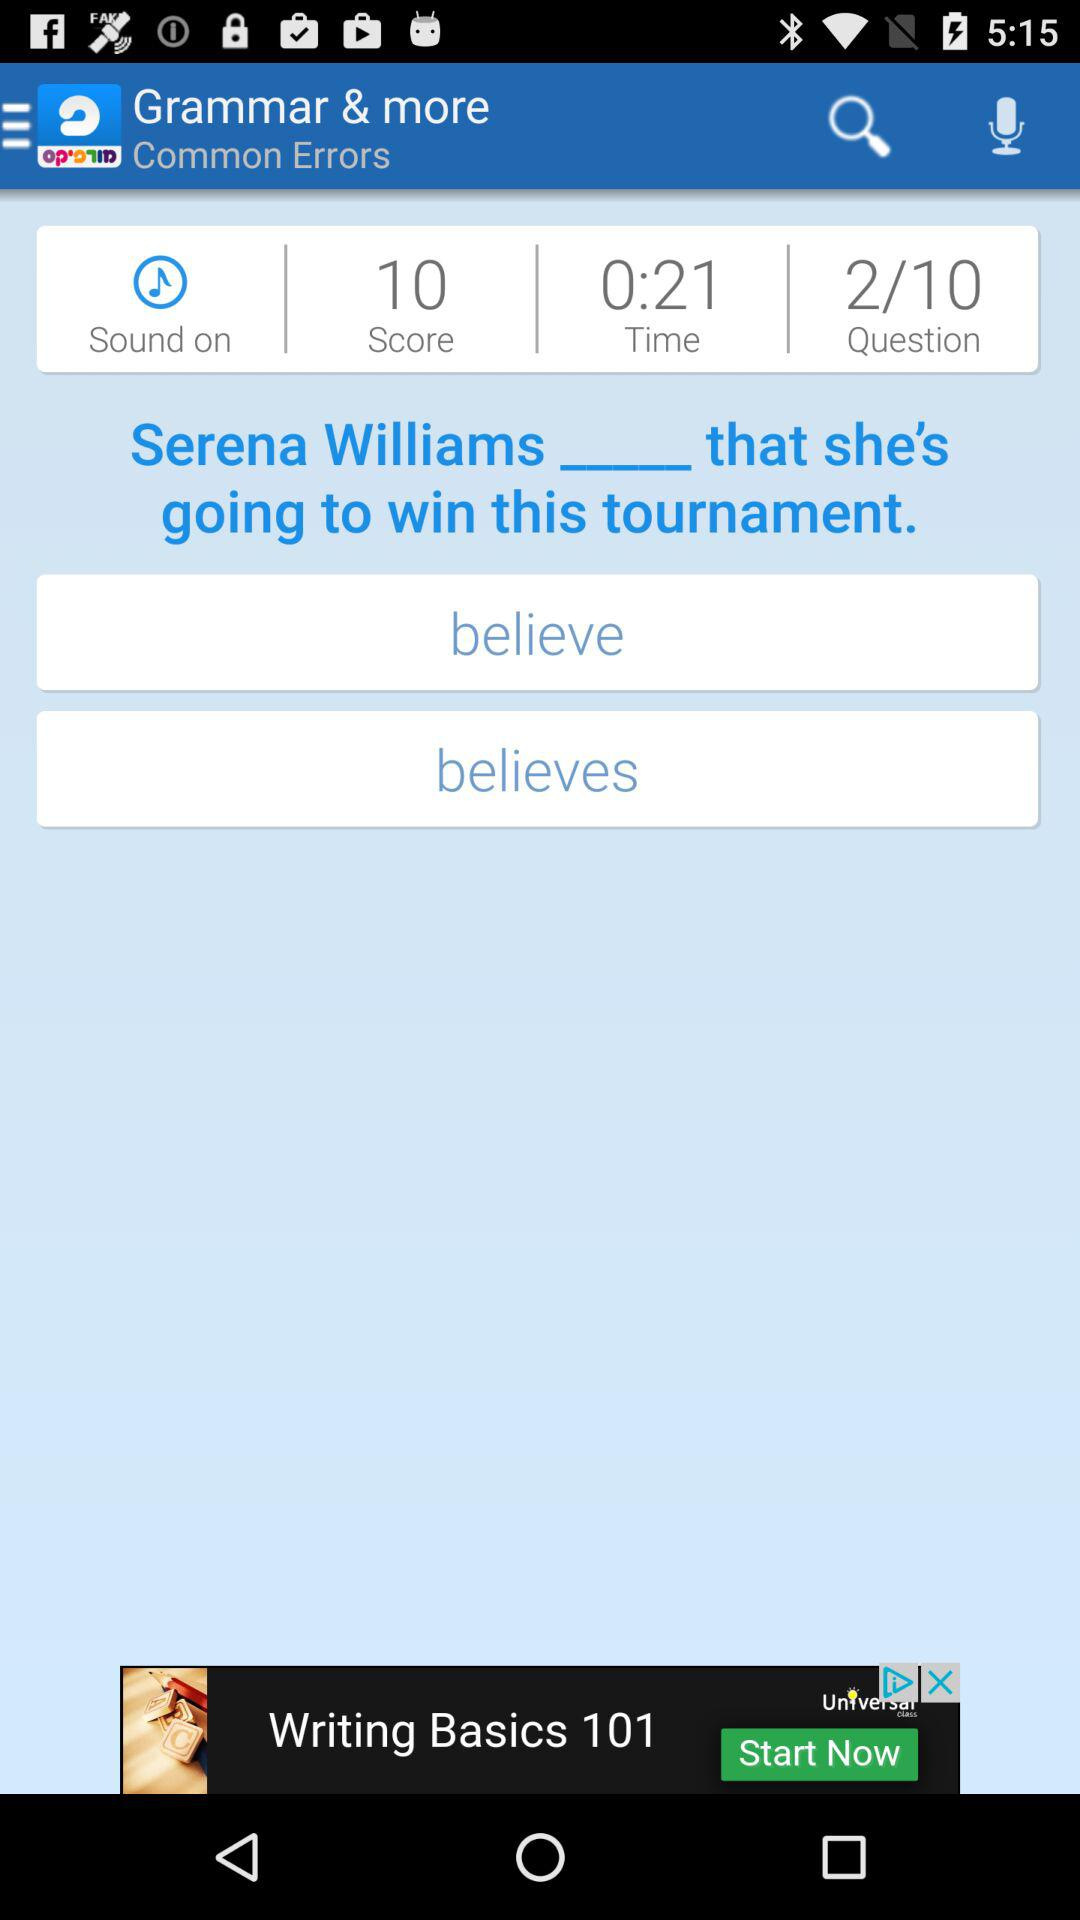What is the score? The score is 10. 